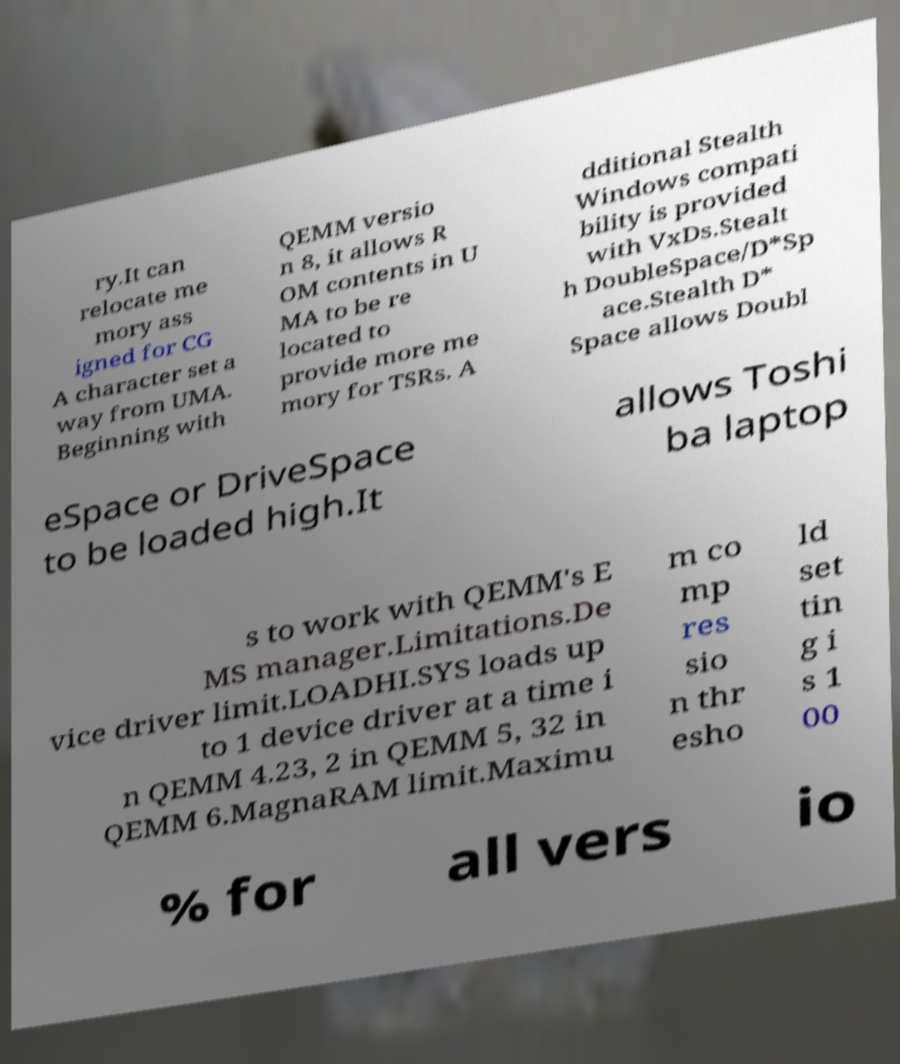Could you extract and type out the text from this image? ry.It can relocate me mory ass igned for CG A character set a way from UMA. Beginning with QEMM versio n 8, it allows R OM contents in U MA to be re located to provide more me mory for TSRs. A dditional Stealth Windows compati bility is provided with VxDs.Stealt h DoubleSpace/D*Sp ace.Stealth D* Space allows Doubl eSpace or DriveSpace to be loaded high.It allows Toshi ba laptop s to work with QEMM's E MS manager.Limitations.De vice driver limit.LOADHI.SYS loads up to 1 device driver at a time i n QEMM 4.23, 2 in QEMM 5, 32 in QEMM 6.MagnaRAM limit.Maximu m co mp res sio n thr esho ld set tin g i s 1 00 % for all vers io 